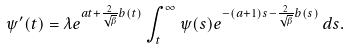<formula> <loc_0><loc_0><loc_500><loc_500>\psi ^ { \prime } ( t ) = \lambda e ^ { a t + \frac { 2 } { \sqrt { \beta } } b ( t ) } \int _ { t } ^ { \infty } \psi ( s ) e ^ { - ( a + 1 ) s - \frac { 2 } { \sqrt { \beta } } b ( s ) } \, d s .</formula> 